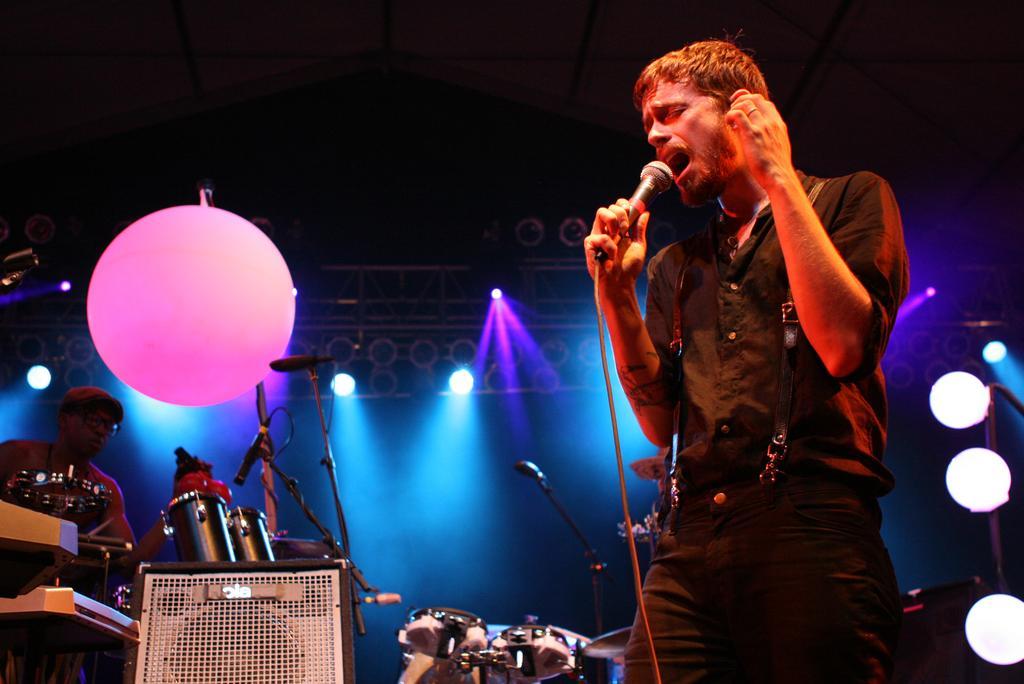Please provide a concise description of this image. In the image we can see a man standing, wearing clothes and holding a microphone in his hand, he is singing. There is a balloon, musical instrument, chair and lights. There is a fingering in the finger. There is another person wearing cap, clothes and spectacles. 